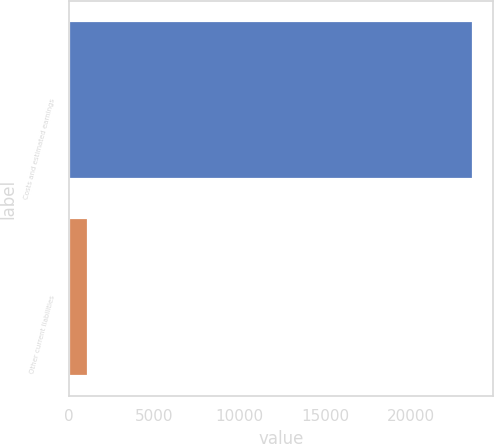Convert chart. <chart><loc_0><loc_0><loc_500><loc_500><bar_chart><fcel>Costs and estimated earnings<fcel>Other current liabilities<nl><fcel>23644<fcel>1120<nl></chart> 